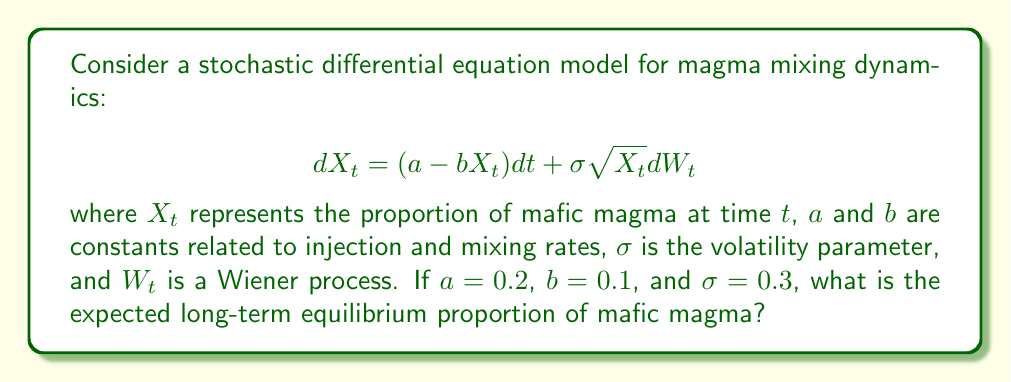Give your solution to this math problem. To find the long-term equilibrium proportion of mafic magma, we need to follow these steps:

1) The given stochastic differential equation (SDE) is of the form:
   $$dX_t = (a - bX_t)dt + \sigma \sqrt{X_t} dW_t$$

2) This SDE follows the Cox-Ingersoll-Ross (CIR) model, which has a known long-term equilibrium distribution.

3) For the CIR model, the long-term equilibrium distribution is a gamma distribution with shape parameter $\frac{2a}{\sigma^2}$ and scale parameter $\frac{\sigma^2}{2b}$.

4) The expected value (mean) of a gamma distribution is the product of its shape and scale parameters.

5) Therefore, the expected long-term equilibrium proportion is:

   $$E[X_\infty] = \frac{2a}{\sigma^2} \cdot \frac{\sigma^2}{2b} = \frac{a}{b}$$

6) Substituting the given values:
   $$E[X_\infty] = \frac{a}{b} = \frac{0.2}{0.1} = 2$$

Thus, the expected long-term equilibrium proportion of mafic magma is 2 or 200%.
Answer: 2 